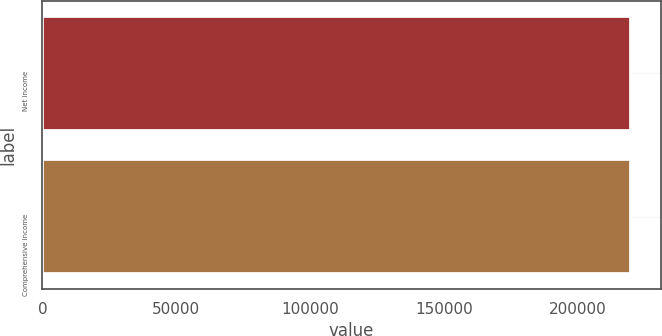Convert chart. <chart><loc_0><loc_0><loc_500><loc_500><bar_chart><fcel>Net income<fcel>Comprehensive income<nl><fcel>219952<fcel>219804<nl></chart> 